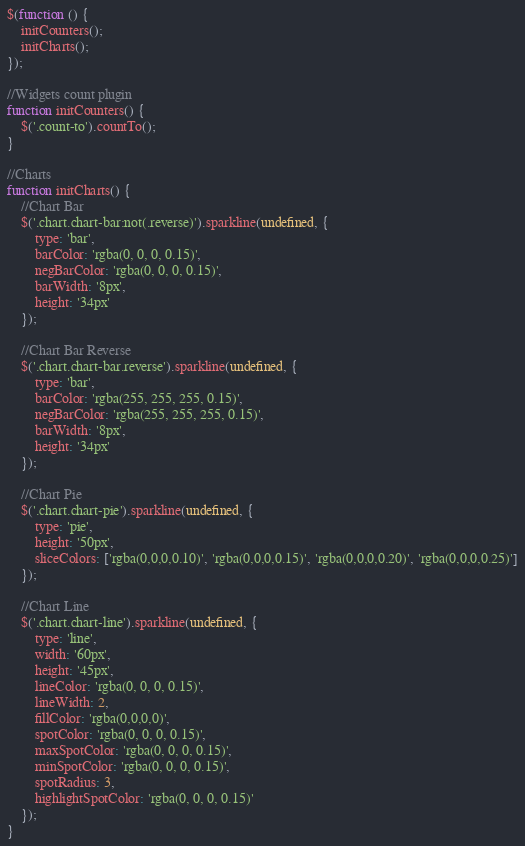Convert code to text. <code><loc_0><loc_0><loc_500><loc_500><_JavaScript_>$(function () {
    initCounters();
    initCharts();
});

//Widgets count plugin
function initCounters() {
    $('.count-to').countTo();
}

//Charts
function initCharts() {
    //Chart Bar
    $('.chart.chart-bar:not(.reverse)').sparkline(undefined, {
        type: 'bar',
        barColor: 'rgba(0, 0, 0, 0.15)',
        negBarColor: 'rgba(0, 0, 0, 0.15)',
        barWidth: '8px',
        height: '34px'
    });

    //Chart Bar Reverse
    $('.chart.chart-bar.reverse').sparkline(undefined, {
        type: 'bar',
        barColor: 'rgba(255, 255, 255, 0.15)',
        negBarColor: 'rgba(255, 255, 255, 0.15)',
        barWidth: '8px',
        height: '34px'
    });

    //Chart Pie
    $('.chart.chart-pie').sparkline(undefined, {
        type: 'pie',
        height: '50px',
        sliceColors: ['rgba(0,0,0,0.10)', 'rgba(0,0,0,0.15)', 'rgba(0,0,0,0.20)', 'rgba(0,0,0,0.25)']
    });

    //Chart Line
    $('.chart.chart-line').sparkline(undefined, {
        type: 'line',
        width: '60px',
        height: '45px',
        lineColor: 'rgba(0, 0, 0, 0.15)',
        lineWidth: 2,
        fillColor: 'rgba(0,0,0,0)',
        spotColor: 'rgba(0, 0, 0, 0.15)',
        maxSpotColor: 'rgba(0, 0, 0, 0.15)',
        minSpotColor: 'rgba(0, 0, 0, 0.15)',
        spotRadius: 3,
        highlightSpotColor: 'rgba(0, 0, 0, 0.15)'
    });
}</code> 